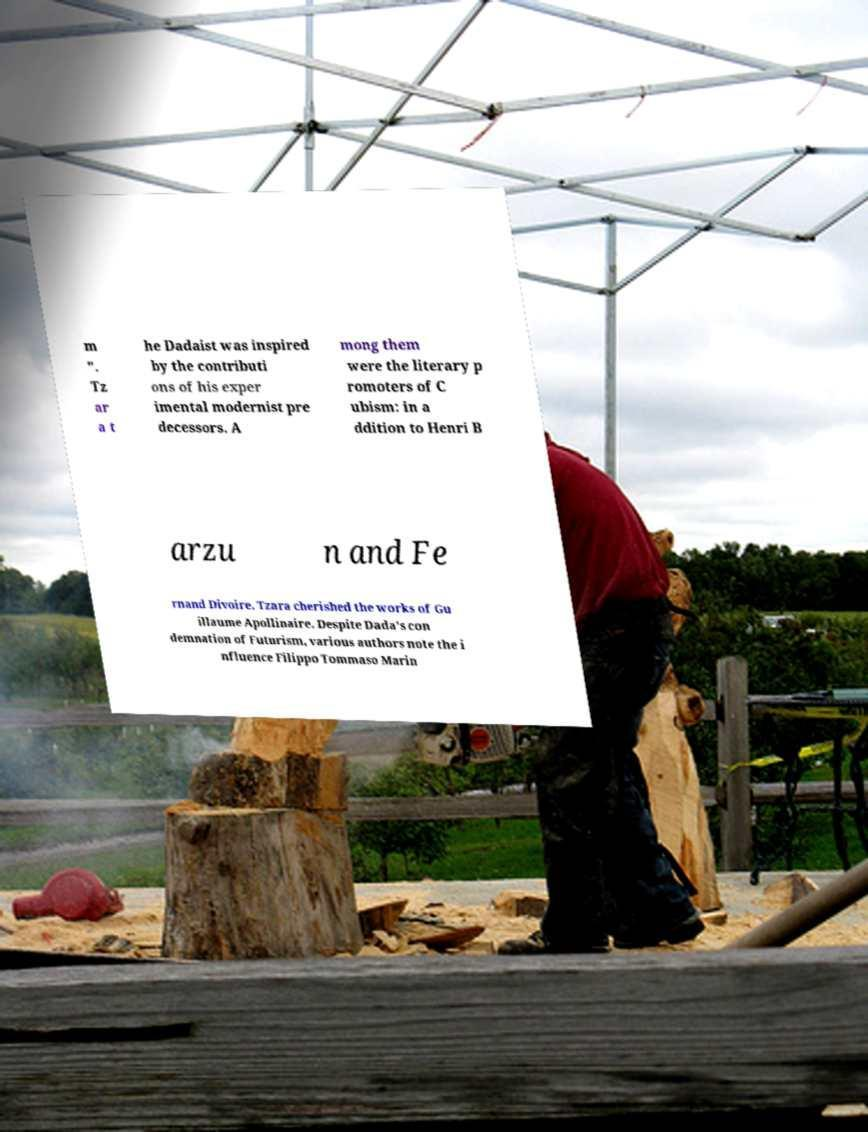There's text embedded in this image that I need extracted. Can you transcribe it verbatim? m ". Tz ar a t he Dadaist was inspired by the contributi ons of his exper imental modernist pre decessors. A mong them were the literary p romoters of C ubism: in a ddition to Henri B arzu n and Fe rnand Divoire, Tzara cherished the works of Gu illaume Apollinaire. Despite Dada's con demnation of Futurism, various authors note the i nfluence Filippo Tommaso Marin 